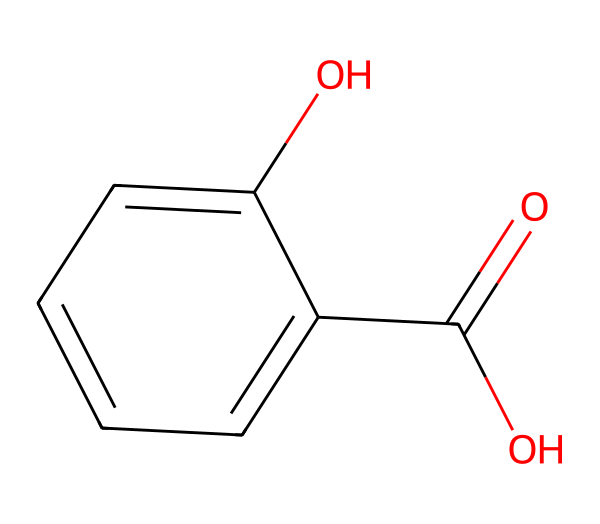What is the molecular formula of this chemical? To find the molecular formula, count the number of each type of atom represented in the SMILES. The structure implies the presence of 7 carbon (C) atoms, 6 hydrogen (H) atoms, and 3 oxygen (O) atoms. Thus, the molecular formula is C7H6O3.
Answer: C7H6O3 How many rings are in this structure? Examining the drawn structure shows that there is one benzene ring, which consists of 6 carbon atoms forming a cyclic structure. There are no additional rings present in the compound.
Answer: 1 What type of acid is this compound? The presence of the carboxylic acid functional group (-COOH) indicates that this compound is an organic acid, specifically a phenolic acid due to its aromatic ring.
Answer: phenolic acid What is the effect of this chemical on plant stress responses? Salicylic acid, the name derived from the compound shown, is known to act as a signaling molecule that can enhance plant tolerance to stress conditions like drought and high salinity by modulating physiological processes.
Answer: enhances tolerance Which functional group classifies this compound as an acid? The presence of the -COOH (carboxylic acid) group defines this compound as an acid. It is the functional group that donates protons (H+) in a chemical reaction, which is characteristic of acids.
Answer: -COOH How many oxygen atoms are in the structure? Counting the atoms from the SMILES representation, there are three oxygen atoms clearly indicated in the structure.
Answer: 3 